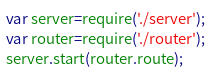Convert code to text. <code><loc_0><loc_0><loc_500><loc_500><_JavaScript_>var server=require('./server');
var router=require('./router');
server.start(router.route);
</code> 